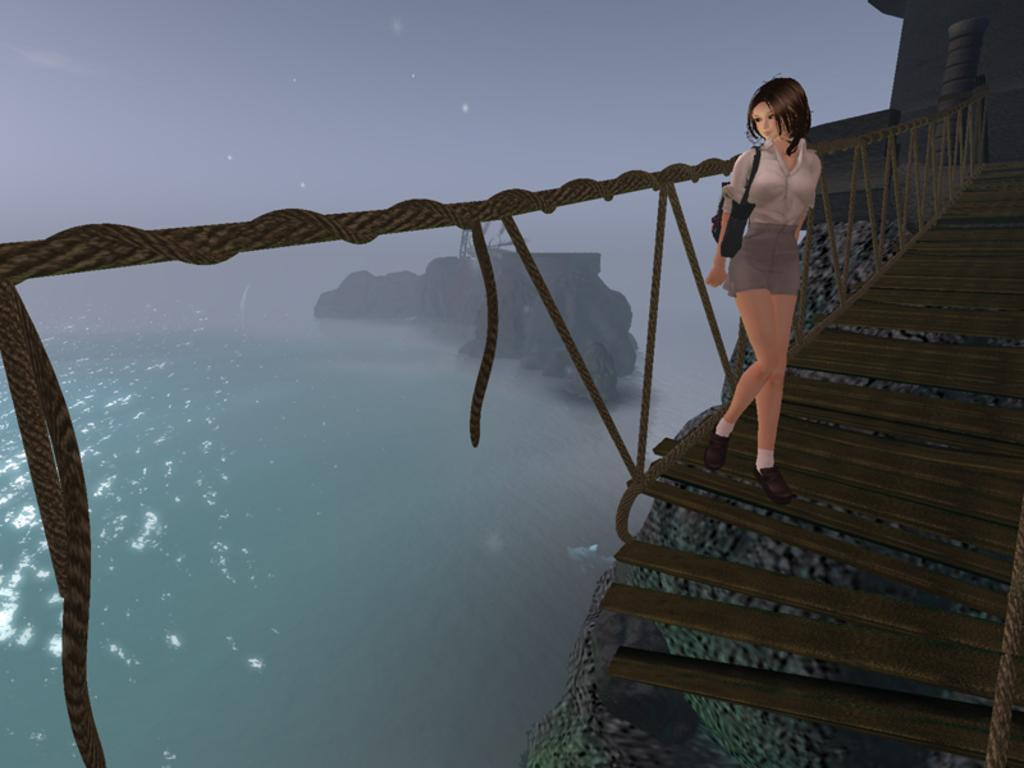What type of picture is shown in the image? The image is an animated picture. Can you describe the setting of the image? There is a person on a wooden bridge, and there are rocks and water visible in the image. What can be seen in the sky in the image? The sky is visible in the image. What type of owl can be seen sitting on the rocks in the image? There is no owl present in the image; it only features a person on a wooden bridge, rocks, water, and the sky. Can you tell me which key the person is holding in the image? There is no key visible in the image; it only shows a person on a wooden bridge, rocks, water, and the sky. 